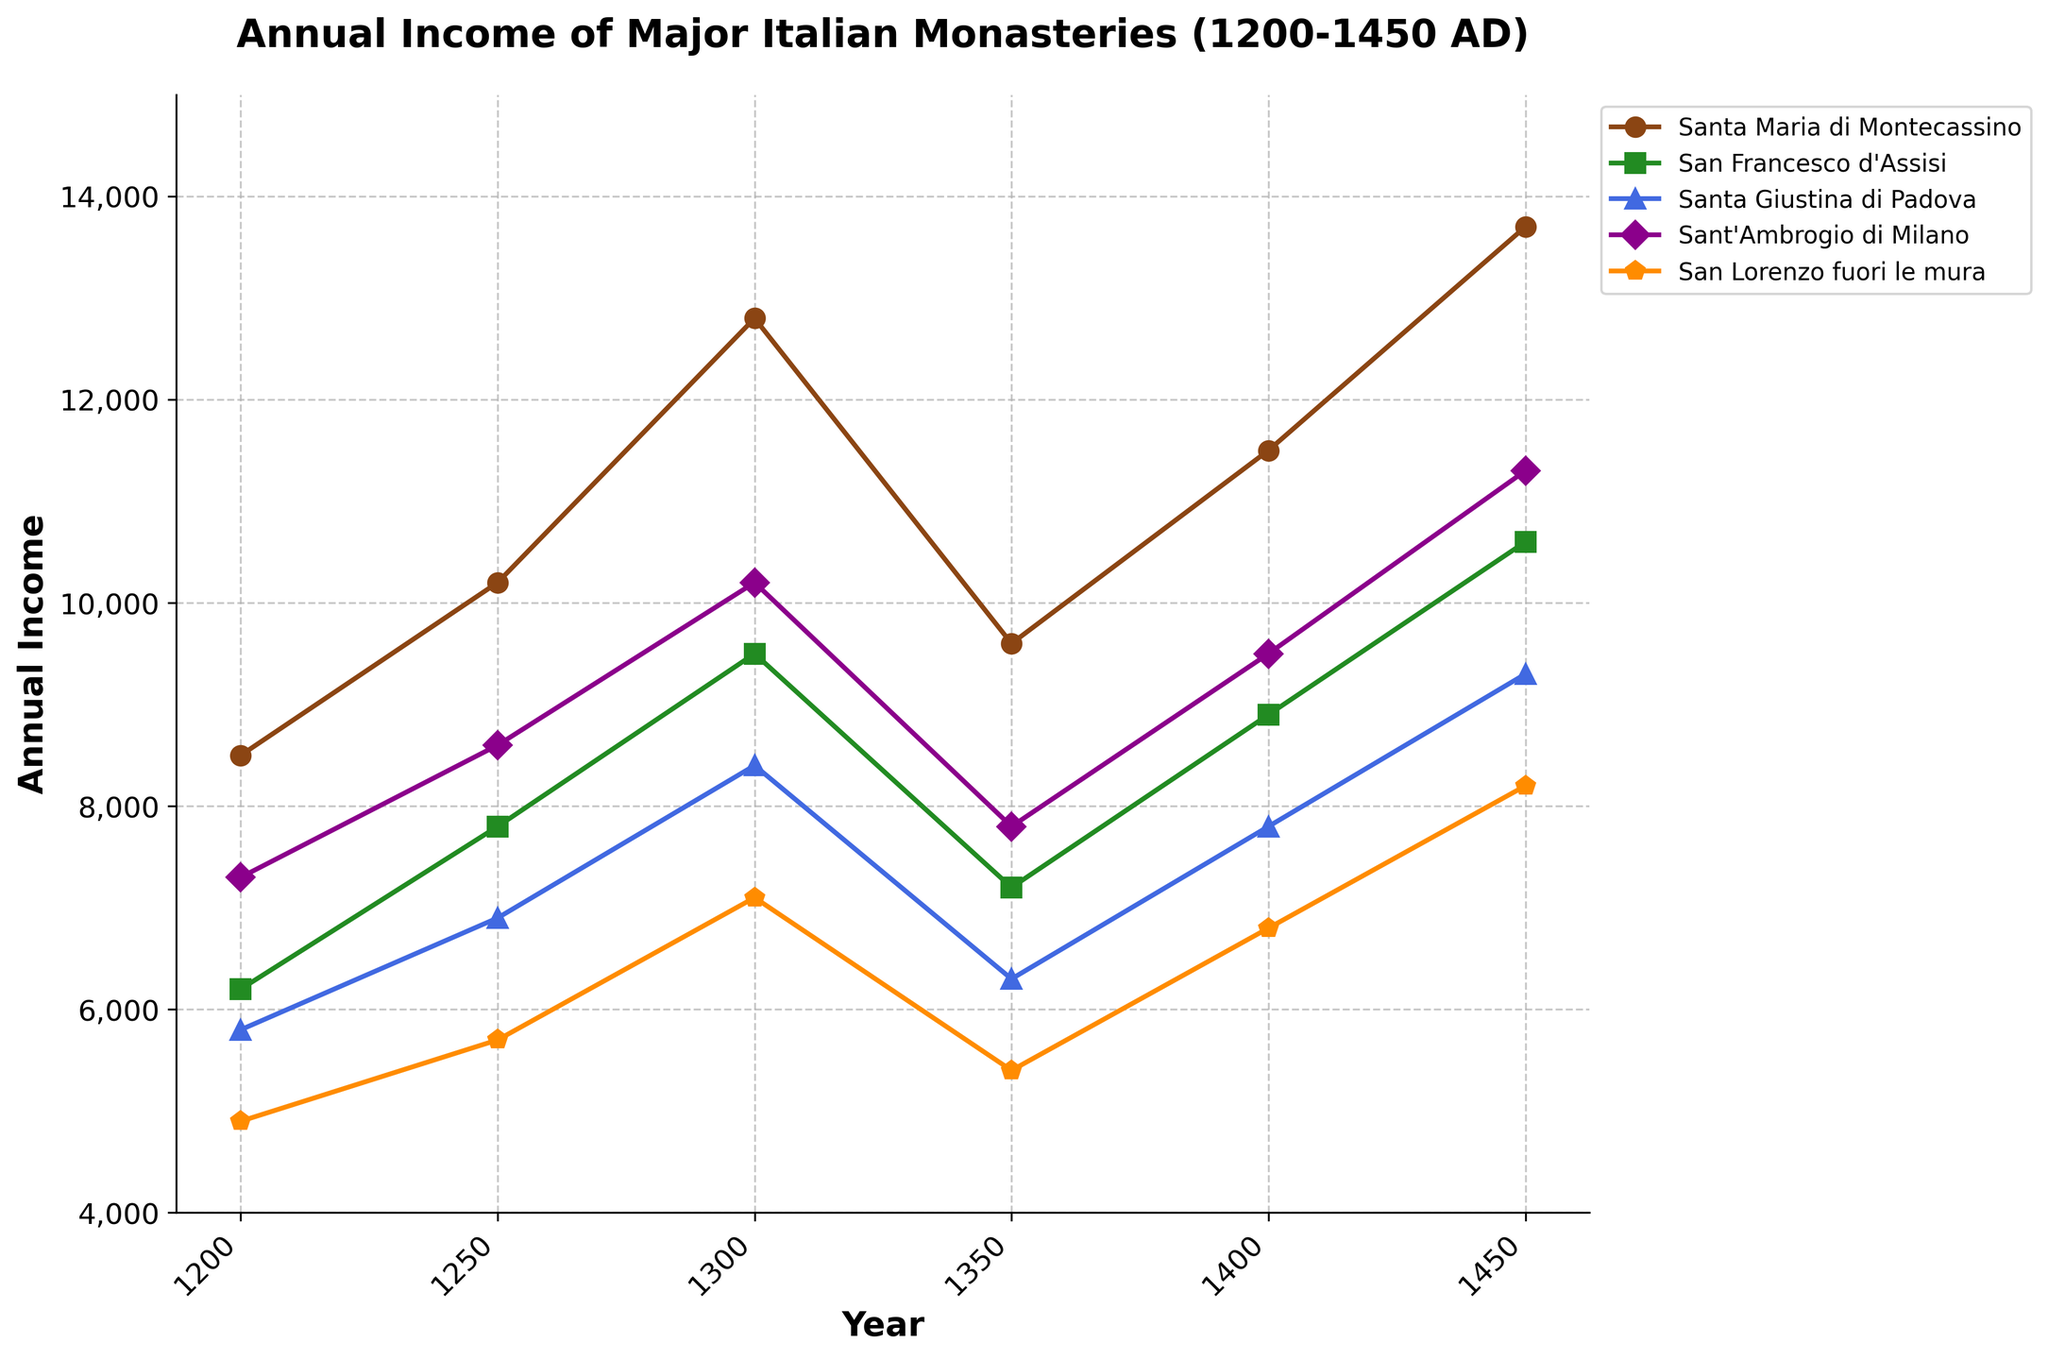What was the annual income of San Francesco d'Assisi in 1250 and 1300? To find the annual income of San Francesco d'Assisi for 1250 and 1300, locate the years on the x-axis and the corresponding values on the y-axis. For 1250, it is 7800, and for 1300, it is 9500.
Answer: 7800, 9500 Which monastery had the highest annual income in 1450? Examine the annual incomes of each monastery for the year 1450, comparing the values. Santa Maria di Montecassino has the highest income at 13700.
Answer: Santa Maria di Montecassino What is the average annual income of Santa Giustina di Padova across all years? To find the average annual income, sum the income values for Santa Giustina di Padova across all given years (5800 + 6900 + 8400 + 6300 + 7800 + 9300). The total is 44500, and there are 6 data points, so the average is 44500 / 6.
Answer: 7416.67 Between 1200 and 1350, which monastery saw a decrease in annual income? Compare the annual incomes in 1200 and 1350 for each monastery. Both Santa Maria di Montecassino and San Francesco d'Assisi saw decreases from 1200 (8500 to 9600 for Santa Maria di Montecassino and 6200 to 7200 for San Francesco d'Assisi).
Answer: None What was the overall trend in the annual income of Sant'Ambrogio di Milano from 1200 to 1450? Observe the values of Sant'Ambrogio di Milano from 1200 (7300) to 1450 (11300). The trend shows a general increase with slight fluctuations, particularly a decrease around 1350.
Answer: Increasing trend How does the annual income of San Lorenzo fuori le mura in 1350 compare to its income in 1450? For San Lorenzo fuori le mura, compare the values of 5400 in 1350 and 8200 in 1450. The income increased from 1350 to 1450.
Answer: Increased What is the combined annual income of all monasteries in 1400? Sum the 1400 incomes: Santa Maria di Montecassino (11500), San Francesco d'Assisi (8900), Santa Giustina di Padova (7800), Sant'Ambrogio di Milano (9500), and San Lorenzo fuori le mura (6800). The combined income is 44500.
Answer: 44500 Which monastery shows the smallest fluctuation in annual income throughout the period? Calculate the range (max - min) for each monastery. The smallest fluctuation: Santa Giustina di Padova, with min=5800 and max=9300, range=3500.
Answer: Santa Giustina di Padova What was the percentage increase in the annual income of Santa Maria di Montecassino from 1200 to 1450? Use the formula: ((final value - initial value) / initial value) * 100. For Santa Maria di Montecassino: ((13700 - 8500) / 8500) * 100 = 61.18%.
Answer: 61.18% Compare the annual income in 1400 between San Francesco d'Assisi and Sant'Ambrogio di Milano. San Francesco d'Assisi had 8900, and Sant'Ambrogio di Milano had 9500 in 1400. Sant'Ambrogio di Milano had a higher income.
Answer: Sant'Ambrogio di Milano 